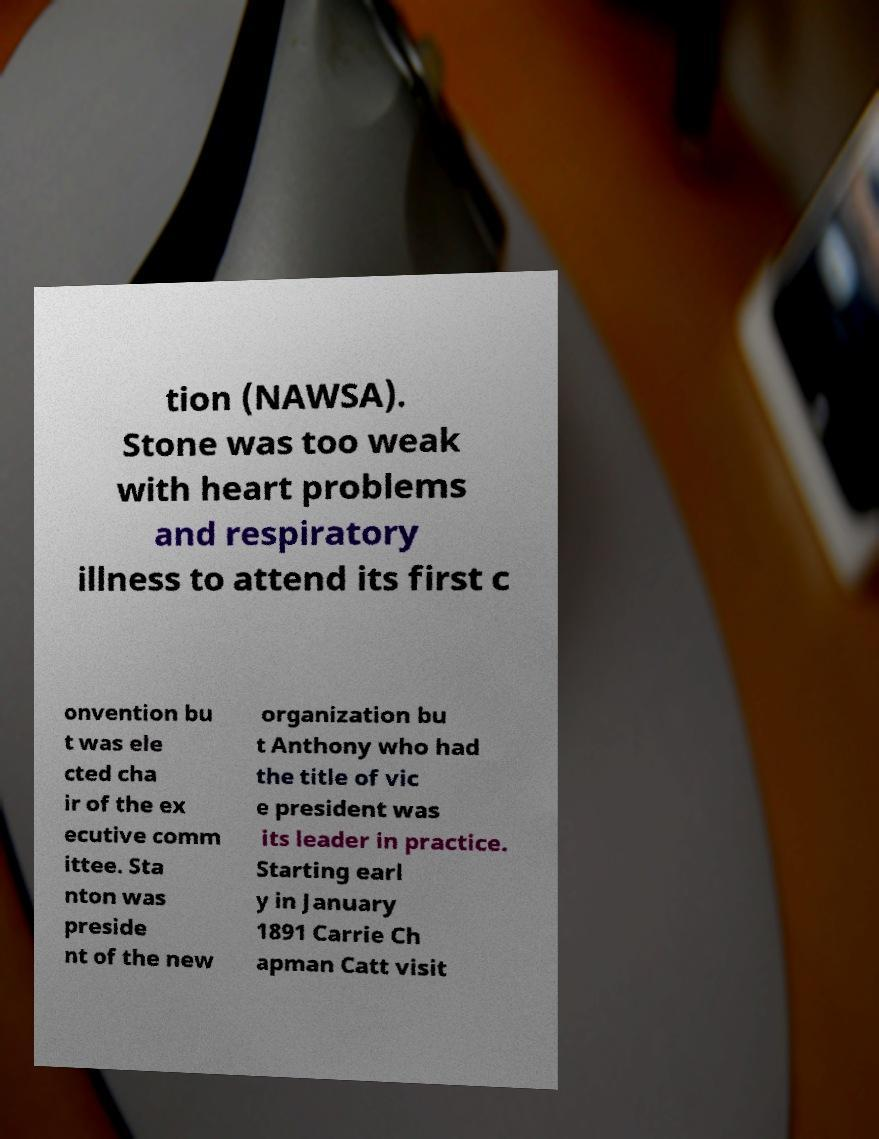Could you assist in decoding the text presented in this image and type it out clearly? tion (NAWSA). Stone was too weak with heart problems and respiratory illness to attend its first c onvention bu t was ele cted cha ir of the ex ecutive comm ittee. Sta nton was preside nt of the new organization bu t Anthony who had the title of vic e president was its leader in practice. Starting earl y in January 1891 Carrie Ch apman Catt visit 